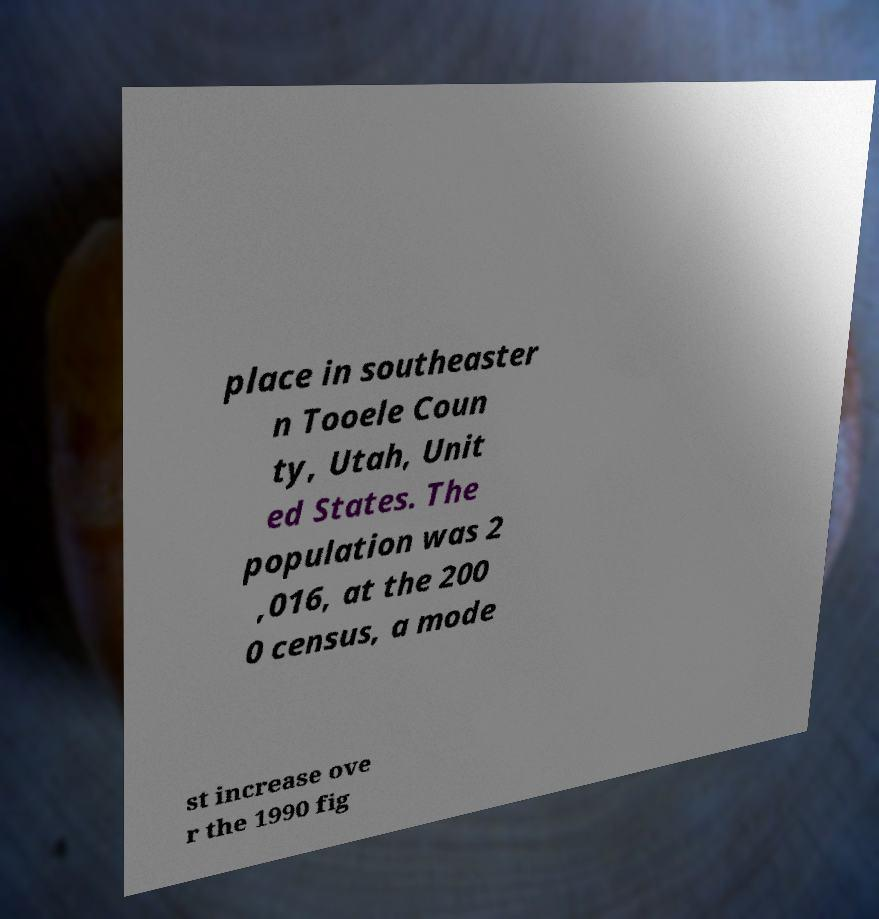Could you extract and type out the text from this image? place in southeaster n Tooele Coun ty, Utah, Unit ed States. The population was 2 ,016, at the 200 0 census, a mode st increase ove r the 1990 fig 